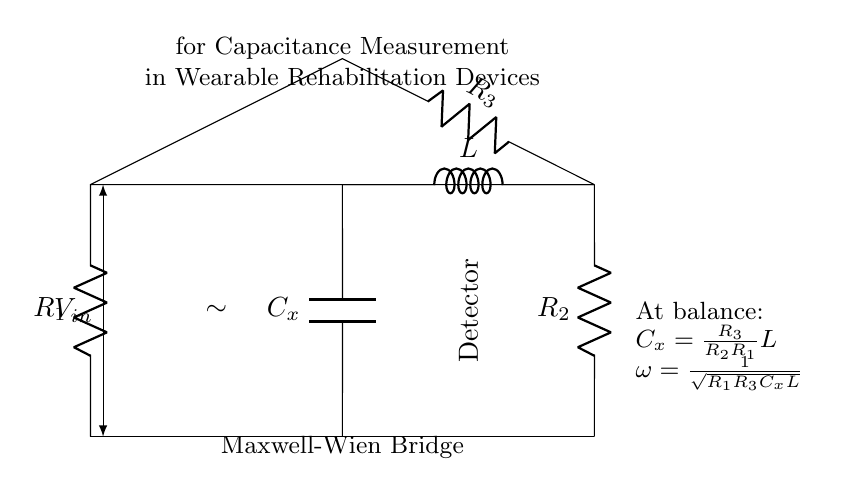What type of bridge is depicted in the circuit? The circuit diagram specifically represents a Maxwell-Wien bridge, which is a type of electrical bridge used for measuring capacitance by balancing the impedance in the circuit.
Answer: Maxwell-Wien bridge What is the primary unknown component measured in this circuit? The circuit is set up to measure the capacitance of a capacitor represented as \(C_x\), indicated in the diagram as the variable component.
Answer: Capacitance What is the relationship between \(C_x\), \(R_2\), \(R_1\), and \(R_3\) at balance? The equation \(C_x = \frac{R_3}{R_2R_1}L\) describes how the capacitance \(C_x\) can be expressed in terms of the resistances \(R_1\), \(R_2\), \(R_3\) and the inductance \(L\) when the bridge is balanced.
Answer: Cx = R3 / (R2 * R1) * L What component in the circuit represents the load? The load in this circuit is represented by the detector, which is shown to measure the output signal of the bridge circuit.
Answer: Detector What condition is indicated for oscillation frequency in this bridge? The formula indicates the frequency at which the bridge oscillates is given by \(\omega = \frac{1}{\sqrt{R_1R_3C_xL}}\) and highlights the interdependencies of the circuit elements.
Answer: ω = 1 / √(R1 * R3 * Cx * L) How many resistors are present in the bridge circuit? The circuit clearly depicts three resistors labeled as \(R_1\), \(R_2\), and \(R_3\), which are crucial for balancing the circuit.
Answer: Three What is the role of the inductor in this Maxwell-Wien bridge? The inductor \(L\) provides the necessary reactance that, along with the capacitive component \(C_x\), enables the measurement of capacitance by balancing the inductive and capacitive reactances in the circuit.
Answer: Inductive reactance 